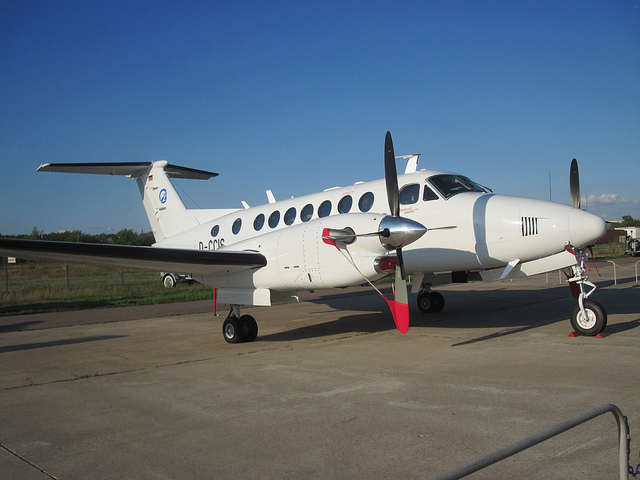<image>What color are the stripes on the plane? There are no stripes on the plane. However, if there were, they may be blue, white, gray or black. What color are the stripes on the plane? There are no stripes on the plane. 